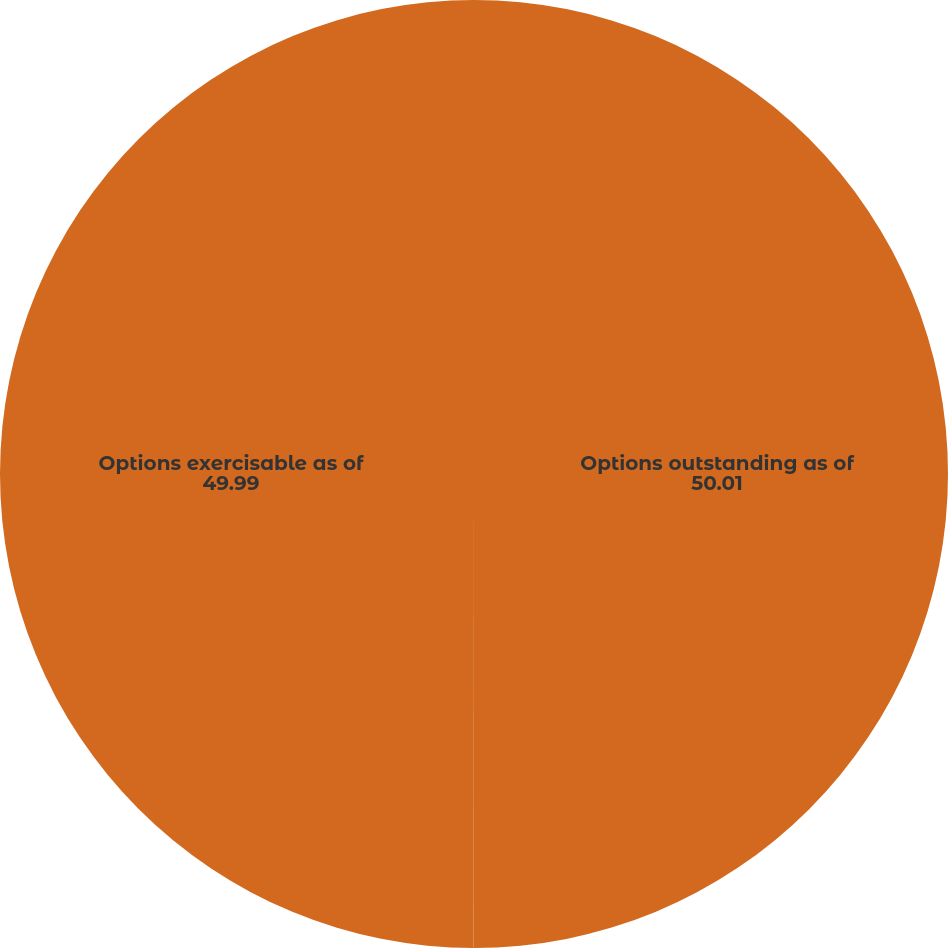<chart> <loc_0><loc_0><loc_500><loc_500><pie_chart><fcel>Options outstanding as of<fcel>Options exercisable as of<nl><fcel>50.01%<fcel>49.99%<nl></chart> 